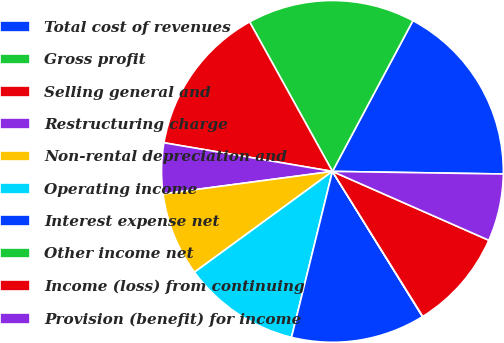Convert chart. <chart><loc_0><loc_0><loc_500><loc_500><pie_chart><fcel>Total cost of revenues<fcel>Gross profit<fcel>Selling general and<fcel>Restructuring charge<fcel>Non-rental depreciation and<fcel>Operating income<fcel>Interest expense net<fcel>Other income net<fcel>Income (loss) from continuing<fcel>Provision (benefit) for income<nl><fcel>17.44%<fcel>15.86%<fcel>14.27%<fcel>4.78%<fcel>7.94%<fcel>11.11%<fcel>12.69%<fcel>0.03%<fcel>9.53%<fcel>6.36%<nl></chart> 